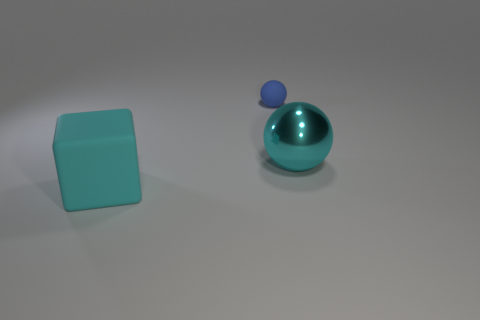Add 2 big cylinders. How many objects exist? 5 Subtract all cubes. How many objects are left? 2 Add 1 big cyan balls. How many big cyan balls are left? 2 Add 1 red things. How many red things exist? 1 Subtract 0 purple blocks. How many objects are left? 3 Subtract all large cyan metallic objects. Subtract all small spheres. How many objects are left? 1 